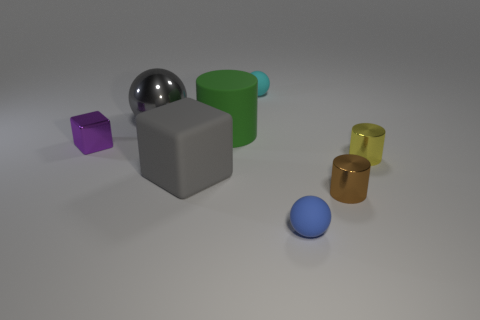Add 2 tiny cyan matte cylinders. How many objects exist? 10 Subtract all blocks. How many objects are left? 6 Subtract 0 cyan cylinders. How many objects are left? 8 Subtract all tiny yellow cylinders. Subtract all tiny cyan balls. How many objects are left? 6 Add 2 big shiny spheres. How many big shiny spheres are left? 3 Add 8 tiny brown objects. How many tiny brown objects exist? 9 